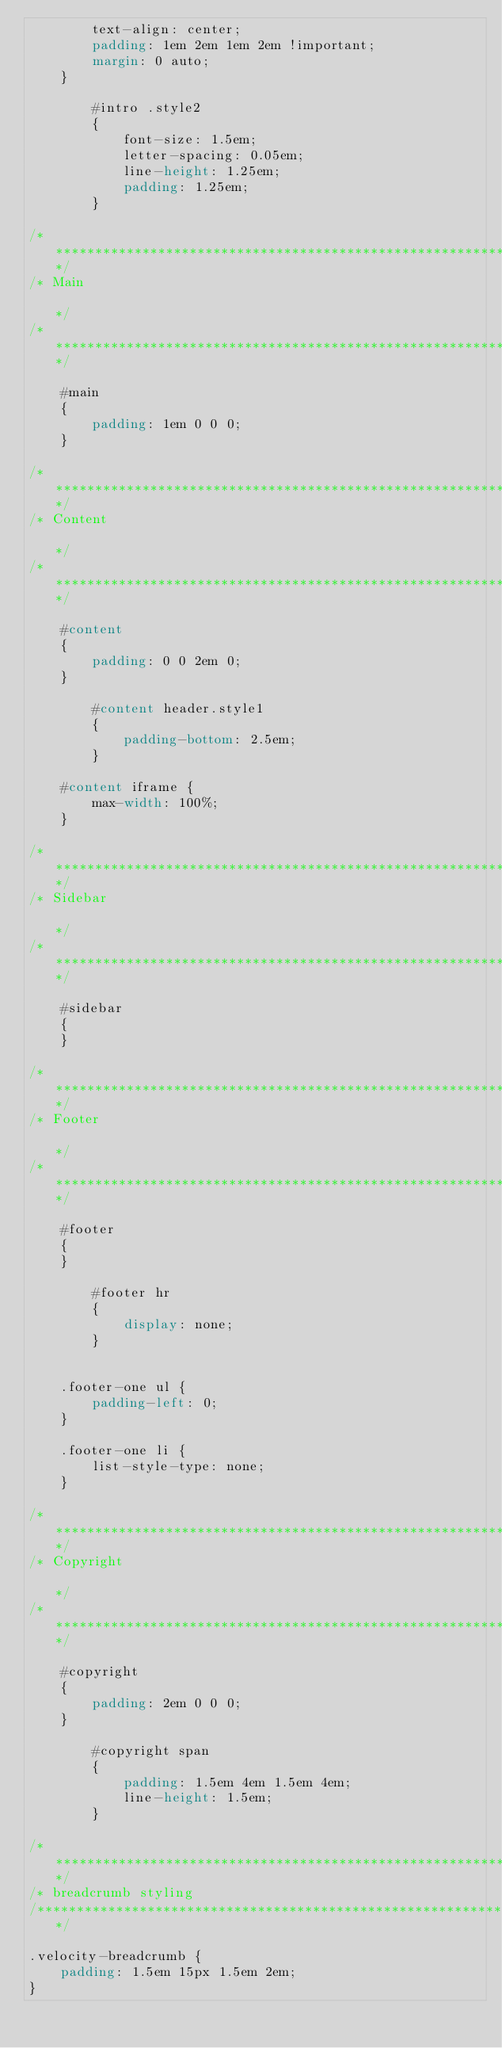<code> <loc_0><loc_0><loc_500><loc_500><_CSS_>        text-align: center;
        padding: 1em 2em 1em 2em !important;
        margin: 0 auto;
    }

        #intro .style2
        {
            font-size: 1.5em;
            letter-spacing: 0.05em;
            line-height: 1.25em;
            padding: 1.25em;
        }

/*********************************************************************************/
/* Main                                                                          */
/*********************************************************************************/

    #main
    {
        padding: 1em 0 0 0;
    }

/*********************************************************************************/
/* Content                                                                       */
/*********************************************************************************/

    #content
    {
        padding: 0 0 2em 0;
    }

        #content header.style1
        {
            padding-bottom: 2.5em;
        }

    #content iframe {
        max-width: 100%;
    }

/*********************************************************************************/
/* Sidebar                                                                       */
/*********************************************************************************/

    #sidebar
    {
    }

/*********************************************************************************/
/* Footer                                                                        */
/*********************************************************************************/

    #footer
    {
    }

        #footer hr
        {
            display: none;
        }


    .footer-one ul {
        padding-left: 0;
    }

    .footer-one li {
        list-style-type: none;
    }

/*********************************************************************************/
/* Copyright                                                                     */
/*********************************************************************************/

    #copyright
    {
        padding: 2em 0 0 0;
    }

        #copyright span
        {
            padding: 1.5em 4em 1.5em 4em;
            line-height: 1.5em;
        }

/*********************************************************************************/
/* breadcrumb styling
/*********************************************************************************/

.velocity-breadcrumb {
    padding: 1.5em 15px 1.5em 2em;
}</code> 